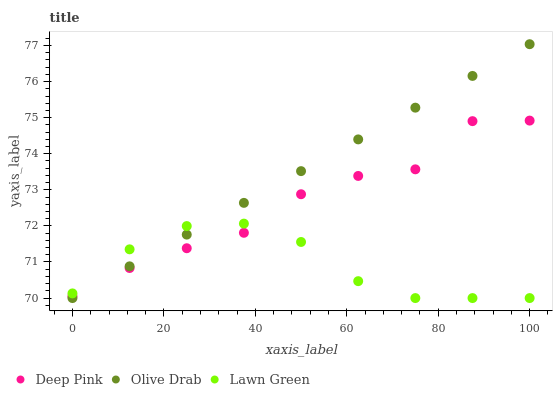Does Lawn Green have the minimum area under the curve?
Answer yes or no. Yes. Does Olive Drab have the maximum area under the curve?
Answer yes or no. Yes. Does Deep Pink have the minimum area under the curve?
Answer yes or no. No. Does Deep Pink have the maximum area under the curve?
Answer yes or no. No. Is Olive Drab the smoothest?
Answer yes or no. Yes. Is Deep Pink the roughest?
Answer yes or no. Yes. Is Deep Pink the smoothest?
Answer yes or no. No. Is Olive Drab the roughest?
Answer yes or no. No. Does Lawn Green have the lowest value?
Answer yes or no. Yes. Does Deep Pink have the lowest value?
Answer yes or no. No. Does Olive Drab have the highest value?
Answer yes or no. Yes. Does Deep Pink have the highest value?
Answer yes or no. No. Does Deep Pink intersect Olive Drab?
Answer yes or no. Yes. Is Deep Pink less than Olive Drab?
Answer yes or no. No. Is Deep Pink greater than Olive Drab?
Answer yes or no. No. 